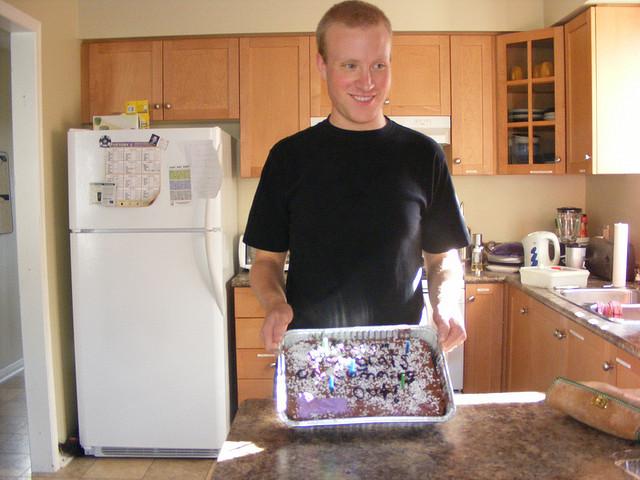What color are the cabinets?
Quick response, please. Brown. Is he pleased with himself?
Give a very brief answer. Yes. Where is the boy sitting?
Be succinct. Kitchen. Is this man cooking at home?
Answer briefly. Yes. Is he baking a cake?
Concise answer only. Yes. 